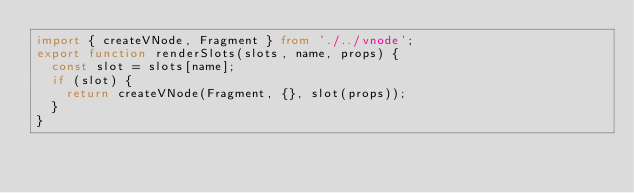Convert code to text. <code><loc_0><loc_0><loc_500><loc_500><_TypeScript_>import { createVNode, Fragment } from './../vnode';
export function renderSlots(slots, name, props) {
  const slot = slots[name];
  if (slot) {
    return createVNode(Fragment, {}, slot(props));
  }
}
</code> 